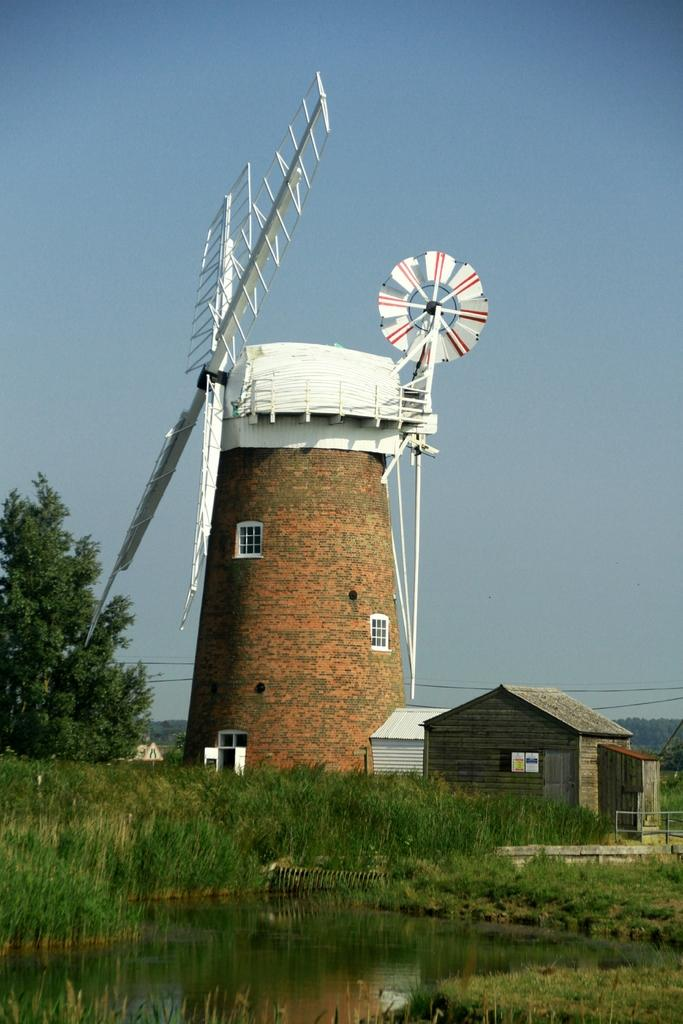What is the main structure in the center of the image? There is a windmill in the center of the image. What other structures can be seen in the image? There are sheds in the image. What is present at the bottom of the image? There is water and grass at the bottom of the image. What can be seen in the background of the image? There are trees, wires, and the sky visible in the background of the image. What type of design is featured on the windmill in the image? The provided facts do not mention any specific design on the windmill, so we cannot answer this question. 